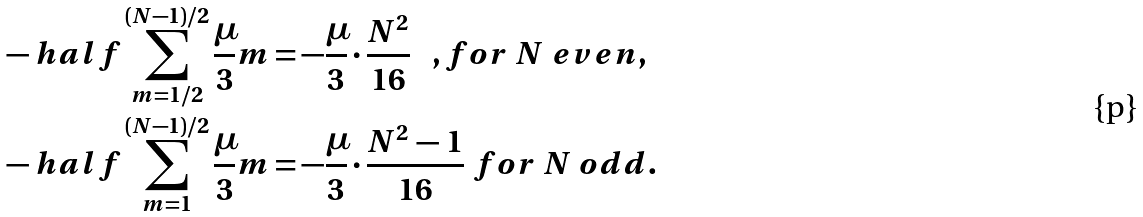<formula> <loc_0><loc_0><loc_500><loc_500>- \ h a l f \sum _ { m = 1 / 2 } ^ { ( N - 1 ) / 2 } \frac { \mu } { 3 } m & = - \frac { \mu } { 3 } \cdot \frac { N ^ { 2 } } { 1 6 } \ \ \ , f o r \ N \ e v e n , \\ - \ h a l f \sum _ { m = 1 } ^ { ( N - 1 ) / 2 } \frac { \mu } { 3 } m & = - \frac { \mu } { 3 } \cdot \frac { N ^ { 2 } \, - \, 1 } { 1 6 } \ f o r \ N \ o d d .</formula> 